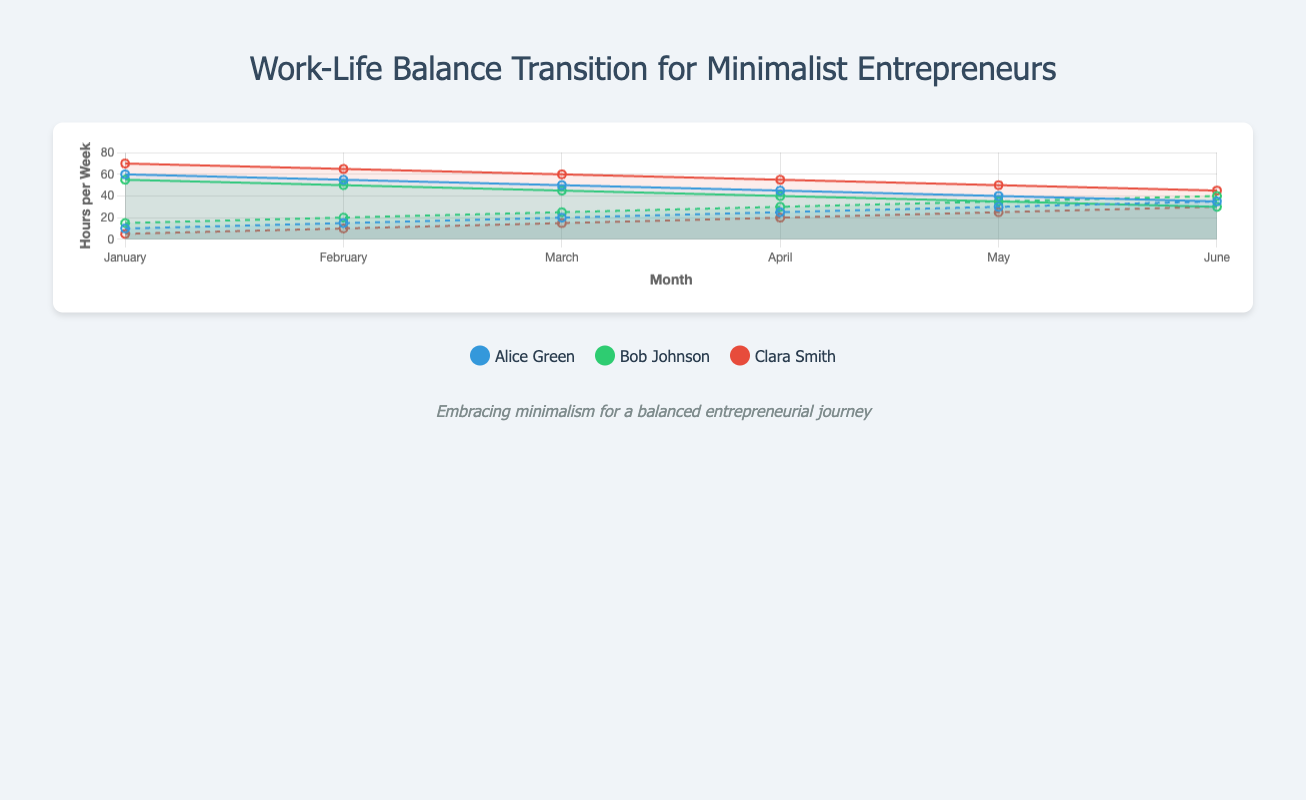What trend is observed in Alice Green's work hours from January to June? By looking at Alice Green’s line plot for work hours, you can see that her hours decrease steadily from 60 to 35 over the six months.
Answer: Decreasing Who spends more hours on life balance in June, Bob Johnson or Clara Smith? In June, Bob Johnson spends 40 hours on life balance, whereas Clara Smith spends 30 hours.
Answer: Bob Johnson How did Clara Smith’s work hours change from January to June? In January, Clara Smith worked 70 hours. This reduced progressively to 45 hours by June.
Answer: Decreasing Calculate the average work hours per week for Alice Green from January to June. The average can be calculated by summing her work hours (60 + 55 + 50 + 45 + 40 + 35) and dividing by 6, which gives (285 / 6) = 47.5 hours.
Answer: 47.5 hours Compare Alice Green's and Bob Johnson's work hours in May. Who worked fewer hours and by how much? In May, Alice Green worked 40 hours and Bob Johnson worked 35 hours. Hence, Bob worked 5 hours fewer than Alice.
Answer: Bob Johnson, 5 hours Which individual had the most significant decrease in work hours from January to June? Clara Smith's work hours decreased from 70 to 45, a reduction of 25 hours. Alice Green's and Bob Johnson's reductions are 25 and 25 hours respectively. Clara’s decrease matches the highest.
Answer: Clara Smith Identify the month when both Bob Johnson and Clara Smith spent the same amount of hours on life balance activities? By checking both data sets for life balance hours, Bob Johnson and Clara Smith both had 30 life balance hours in June.
Answer: June What's the total number of life balance hours for Clara Smith over the entire period? Summing Clara Smith's life balance hours from January to June (5 + 10+ 15 + 20 + 25 + 30) = 105 hours.
Answer: 105 hours 